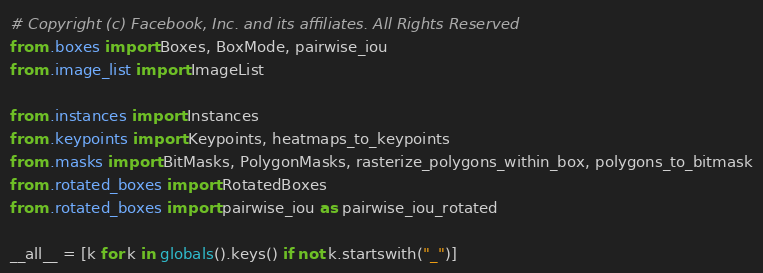<code> <loc_0><loc_0><loc_500><loc_500><_Python_># Copyright (c) Facebook, Inc. and its affiliates. All Rights Reserved
from .boxes import Boxes, BoxMode, pairwise_iou
from .image_list import ImageList

from .instances import Instances
from .keypoints import Keypoints, heatmaps_to_keypoints
from .masks import BitMasks, PolygonMasks, rasterize_polygons_within_box, polygons_to_bitmask
from .rotated_boxes import RotatedBoxes
from .rotated_boxes import pairwise_iou as pairwise_iou_rotated

__all__ = [k for k in globals().keys() if not k.startswith("_")]
</code> 